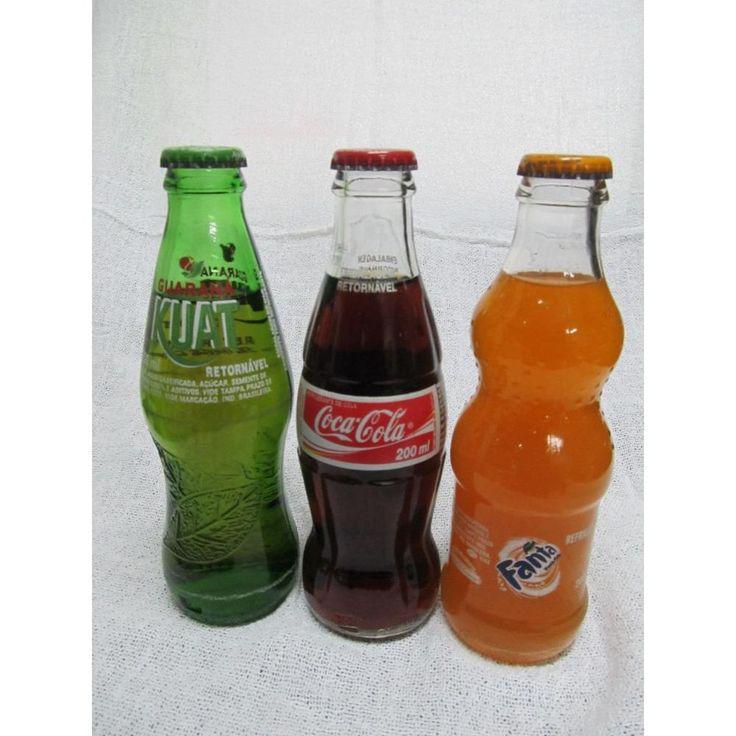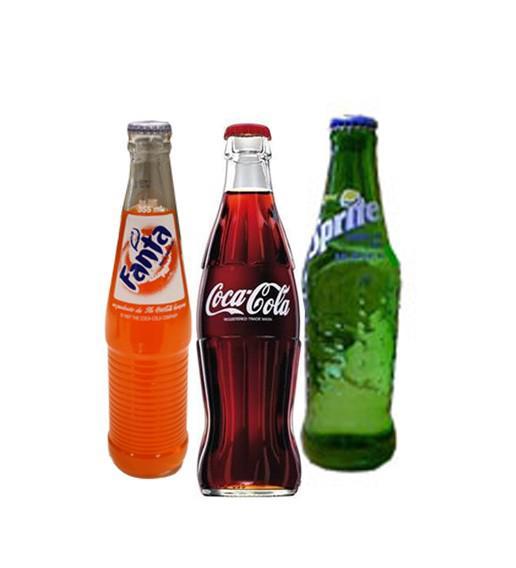The first image is the image on the left, the second image is the image on the right. Evaluate the accuracy of this statement regarding the images: "One of the images includes fewer than three drink containers.". Is it true? Answer yes or no. No. The first image is the image on the left, the second image is the image on the right. Examine the images to the left and right. Is the description "All the containers are plastic." accurate? Answer yes or no. No. 